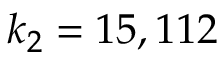<formula> <loc_0><loc_0><loc_500><loc_500>k _ { 2 } = 1 5 , 1 1 2</formula> 